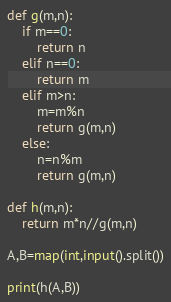<code> <loc_0><loc_0><loc_500><loc_500><_Python_>def g(m,n):
    if m==0:
        return n
    elif n==0:
        return m
    elif m>n:
        m=m%n
        return g(m,n)
    else:
        n=n%m
        return g(m,n)

def h(m,n):
    return m*n//g(m,n)

A,B=map(int,input().split())

print(h(A,B))
</code> 